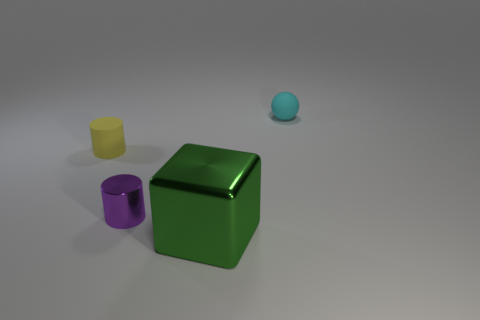Subtract all balls. How many objects are left? 3 Subtract 1 cubes. How many cubes are left? 0 Subtract all gray cylinders. Subtract all blue blocks. How many cylinders are left? 2 Subtract all brown spheres. How many brown cubes are left? 0 Subtract all cylinders. Subtract all tiny yellow cylinders. How many objects are left? 1 Add 2 small rubber things. How many small rubber things are left? 4 Add 1 big yellow objects. How many big yellow objects exist? 1 Add 2 brown blocks. How many objects exist? 6 Subtract all purple cylinders. How many cylinders are left? 1 Subtract 0 gray balls. How many objects are left? 4 